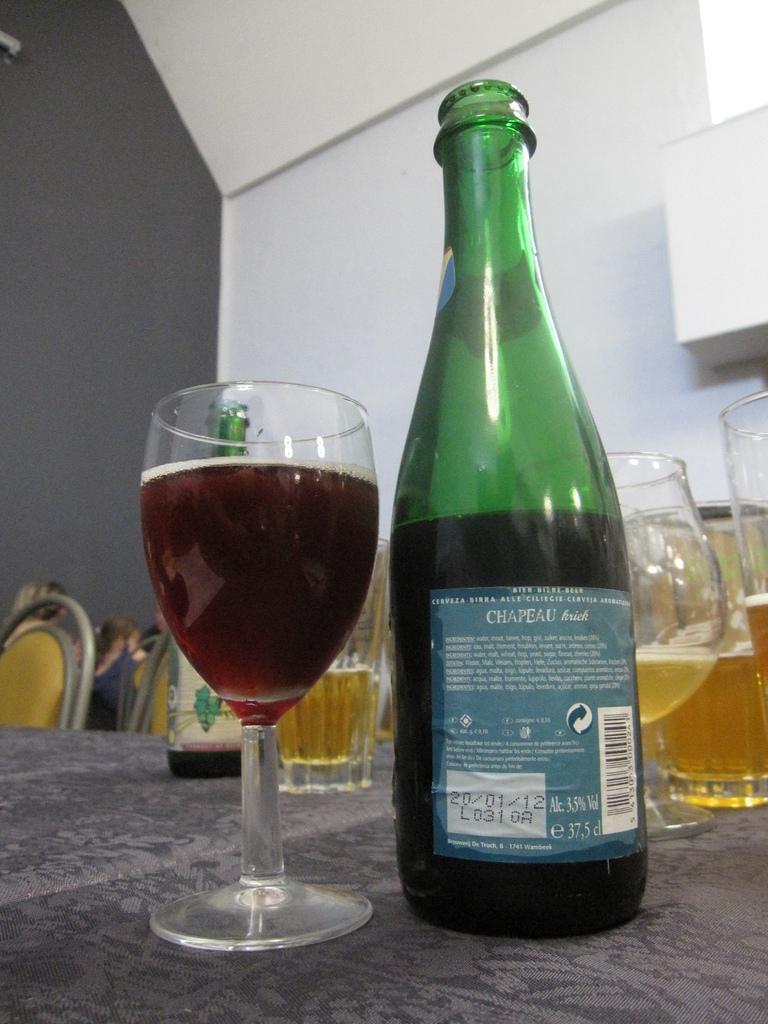Describe this image in one or two sentences. As we can see in the image there is a white color wall, chairs and table. On table there are glasses and bottle. 